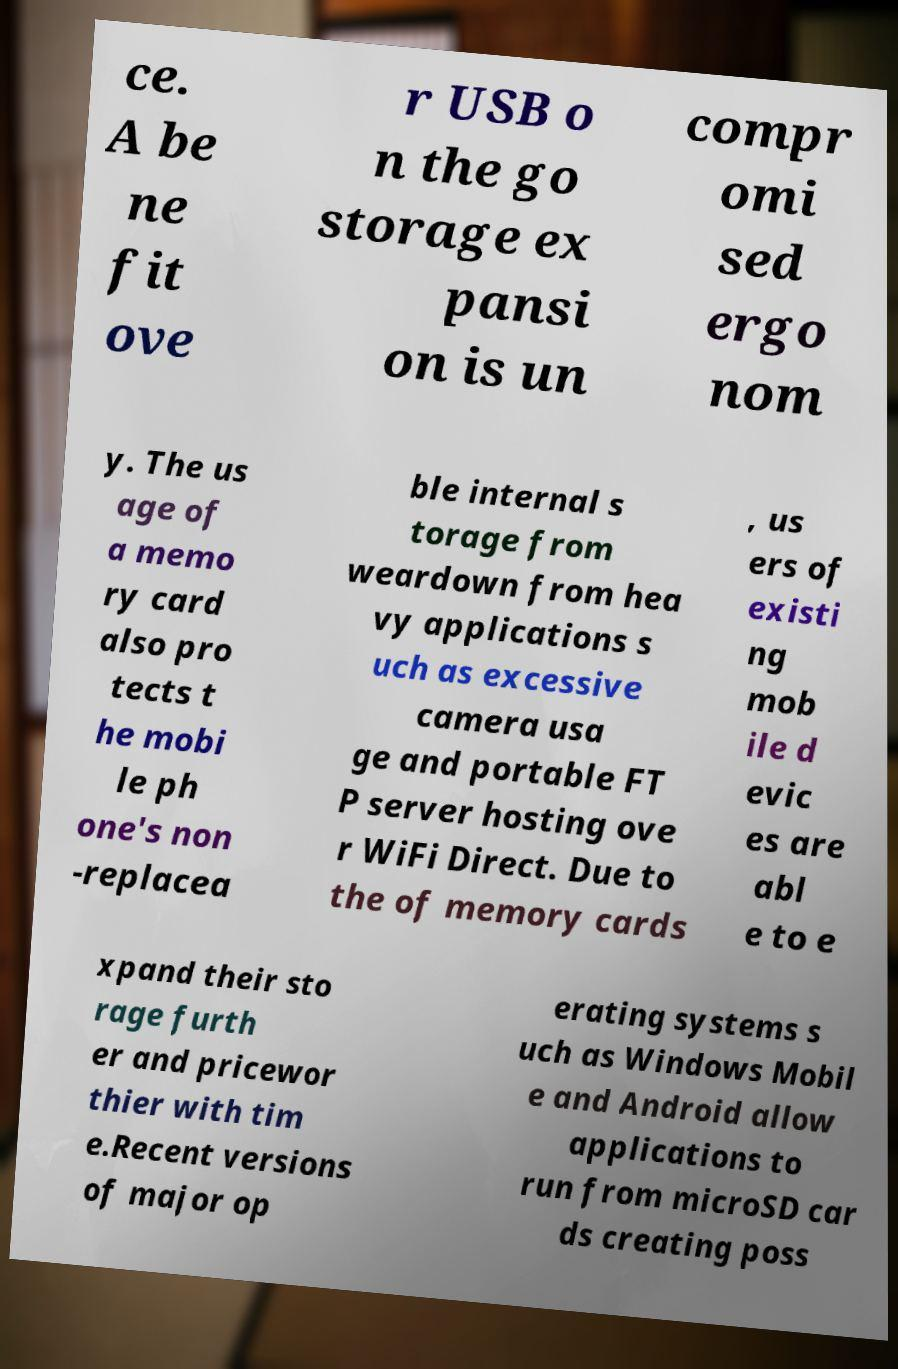Please identify and transcribe the text found in this image. ce. A be ne fit ove r USB o n the go storage ex pansi on is un compr omi sed ergo nom y. The us age of a memo ry card also pro tects t he mobi le ph one's non -replacea ble internal s torage from weardown from hea vy applications s uch as excessive camera usa ge and portable FT P server hosting ove r WiFi Direct. Due to the of memory cards , us ers of existi ng mob ile d evic es are abl e to e xpand their sto rage furth er and pricewor thier with tim e.Recent versions of major op erating systems s uch as Windows Mobil e and Android allow applications to run from microSD car ds creating poss 